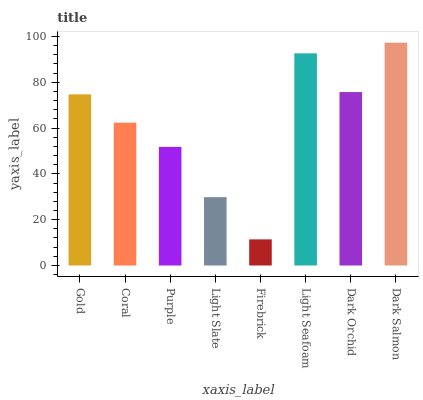Is Firebrick the minimum?
Answer yes or no. Yes. Is Dark Salmon the maximum?
Answer yes or no. Yes. Is Coral the minimum?
Answer yes or no. No. Is Coral the maximum?
Answer yes or no. No. Is Gold greater than Coral?
Answer yes or no. Yes. Is Coral less than Gold?
Answer yes or no. Yes. Is Coral greater than Gold?
Answer yes or no. No. Is Gold less than Coral?
Answer yes or no. No. Is Gold the high median?
Answer yes or no. Yes. Is Coral the low median?
Answer yes or no. Yes. Is Coral the high median?
Answer yes or no. No. Is Dark Salmon the low median?
Answer yes or no. No. 